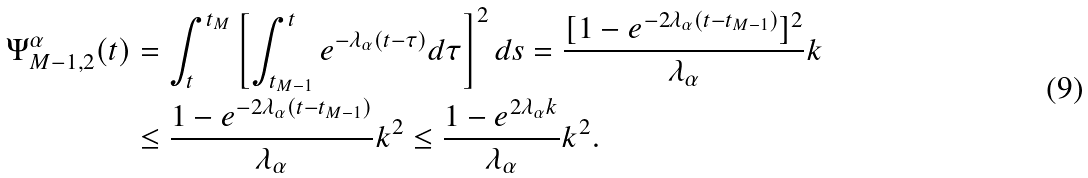Convert formula to latex. <formula><loc_0><loc_0><loc_500><loc_500>\Psi _ { M - 1 , 2 } ^ { \alpha } ( t ) & = \int _ { t } ^ { t _ { M } } \left [ \int _ { t _ { M - 1 } } ^ { t } e ^ { - \lambda _ { \alpha } ( t - \tau ) } d \tau \right ] ^ { 2 } d s = \frac { [ 1 - e ^ { - 2 \lambda _ { \alpha } ( t - t _ { M - 1 } ) } ] ^ { 2 } } { \lambda _ { \alpha } } k \\ & \leq \frac { 1 - e ^ { - 2 \lambda _ { \alpha } ( t - t _ { M - 1 } ) } } { \lambda _ { \alpha } } k ^ { 2 } \leq \frac { 1 - e ^ { 2 \lambda _ { \alpha } k } } { \lambda _ { \alpha } } k ^ { 2 } .</formula> 